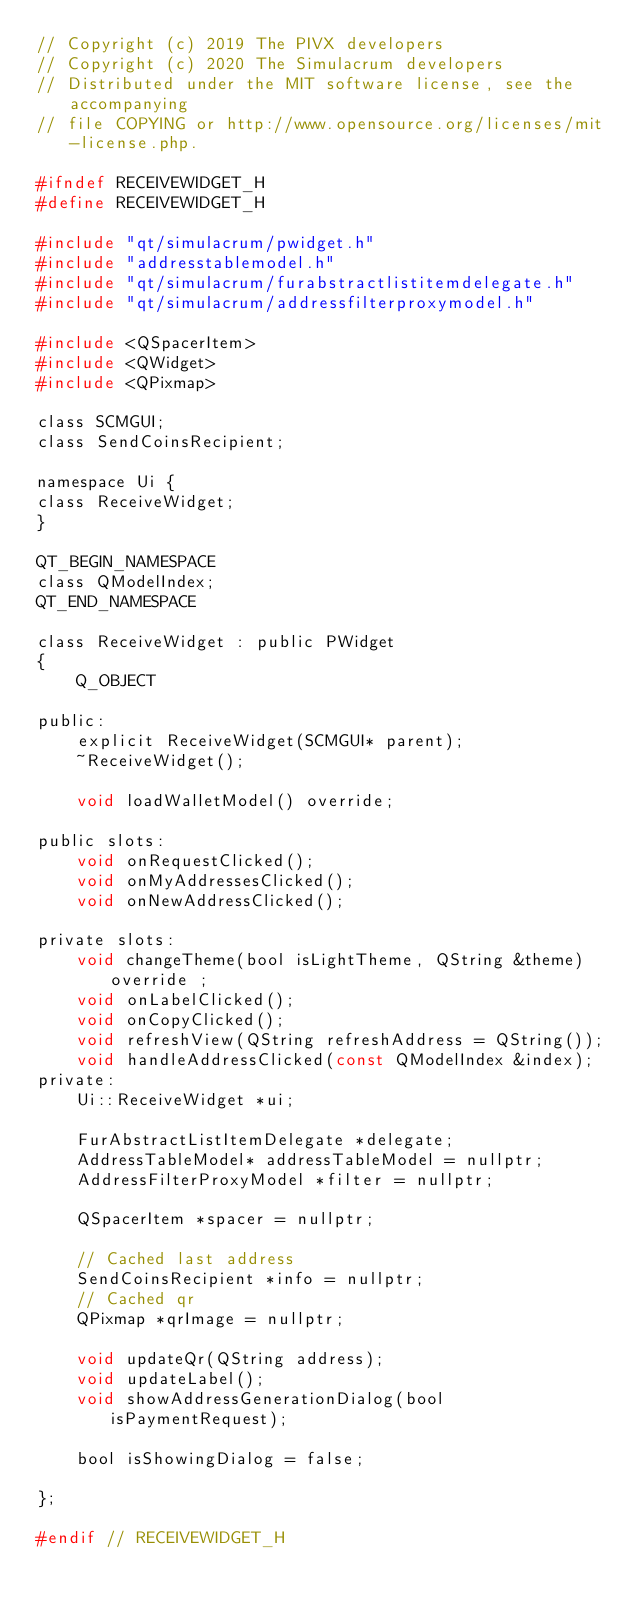Convert code to text. <code><loc_0><loc_0><loc_500><loc_500><_C_>// Copyright (c) 2019 The PIVX developers
// Copyright (c) 2020 The Simulacrum developers
// Distributed under the MIT software license, see the accompanying
// file COPYING or http://www.opensource.org/licenses/mit-license.php.

#ifndef RECEIVEWIDGET_H
#define RECEIVEWIDGET_H

#include "qt/simulacrum/pwidget.h"
#include "addresstablemodel.h"
#include "qt/simulacrum/furabstractlistitemdelegate.h"
#include "qt/simulacrum/addressfilterproxymodel.h"

#include <QSpacerItem>
#include <QWidget>
#include <QPixmap>

class SCMGUI;
class SendCoinsRecipient;

namespace Ui {
class ReceiveWidget;
}

QT_BEGIN_NAMESPACE
class QModelIndex;
QT_END_NAMESPACE

class ReceiveWidget : public PWidget
{
    Q_OBJECT

public:
    explicit ReceiveWidget(SCMGUI* parent);
    ~ReceiveWidget();

    void loadWalletModel() override;

public slots:
    void onRequestClicked();
    void onMyAddressesClicked();
    void onNewAddressClicked();

private slots:
    void changeTheme(bool isLightTheme, QString &theme) override ;
    void onLabelClicked();
    void onCopyClicked();
    void refreshView(QString refreshAddress = QString());
    void handleAddressClicked(const QModelIndex &index);
private:
    Ui::ReceiveWidget *ui;

    FurAbstractListItemDelegate *delegate;
    AddressTableModel* addressTableModel = nullptr;
    AddressFilterProxyModel *filter = nullptr;

    QSpacerItem *spacer = nullptr;

    // Cached last address
    SendCoinsRecipient *info = nullptr;
    // Cached qr
    QPixmap *qrImage = nullptr;

    void updateQr(QString address);
    void updateLabel();
    void showAddressGenerationDialog(bool isPaymentRequest);

    bool isShowingDialog = false;

};

#endif // RECEIVEWIDGET_H
</code> 